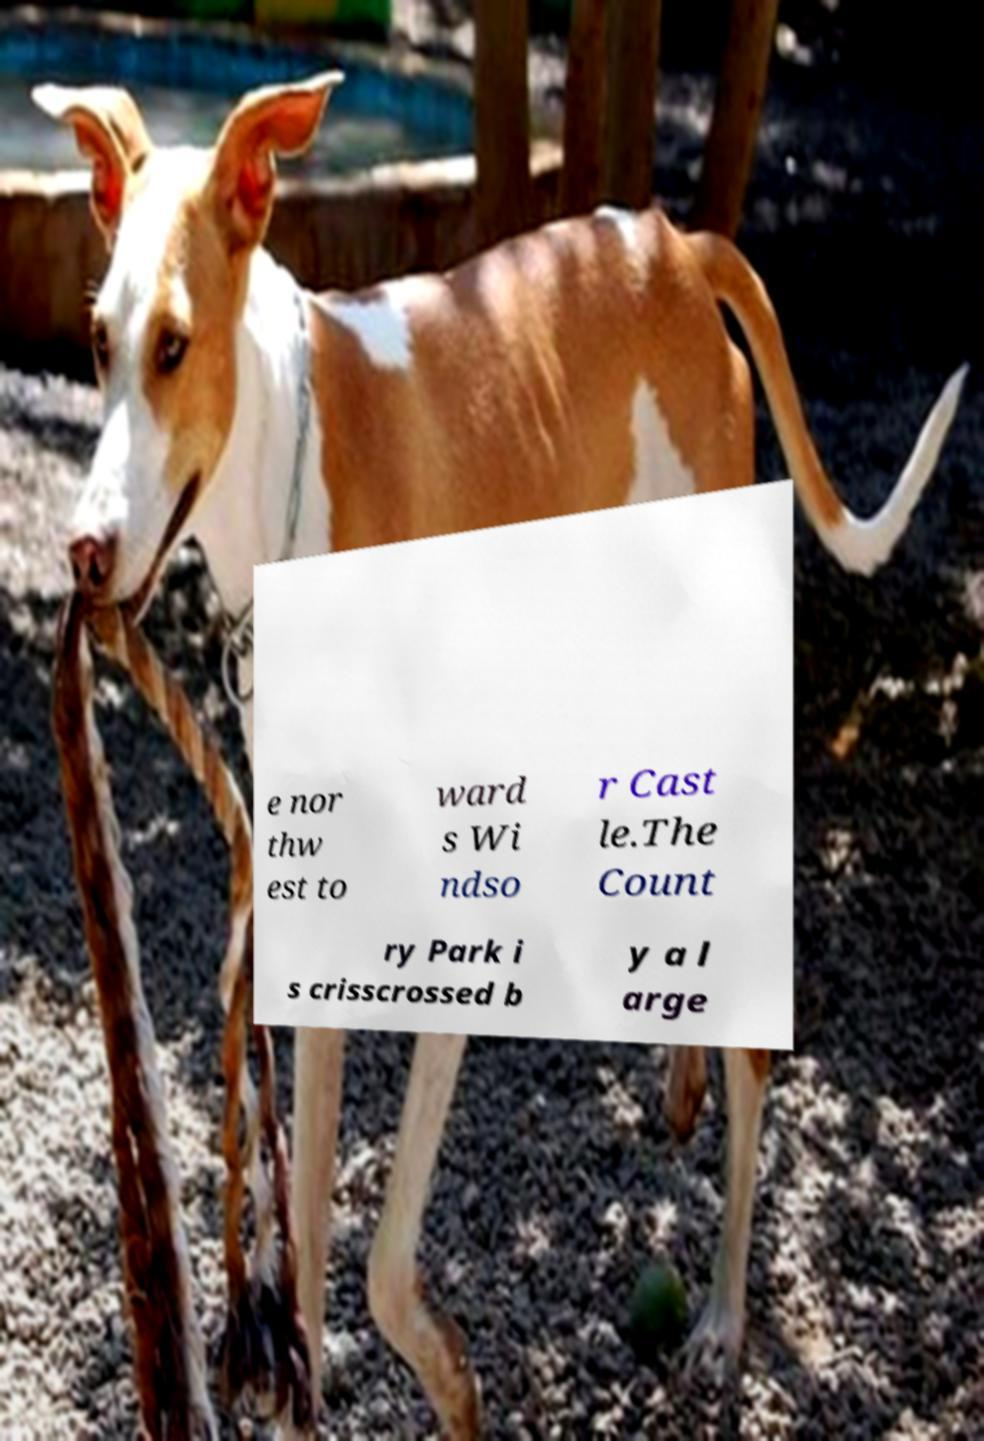I need the written content from this picture converted into text. Can you do that? e nor thw est to ward s Wi ndso r Cast le.The Count ry Park i s crisscrossed b y a l arge 